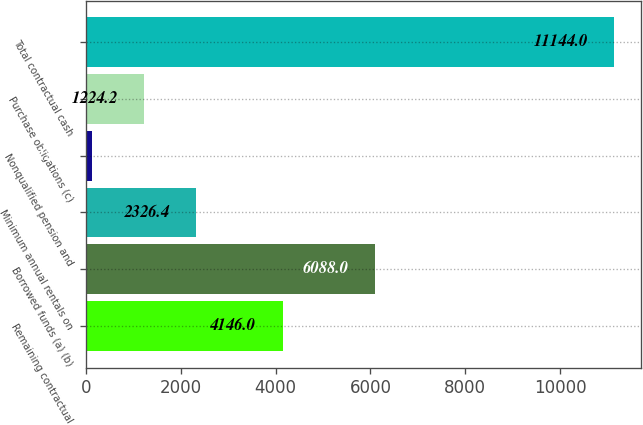Convert chart to OTSL. <chart><loc_0><loc_0><loc_500><loc_500><bar_chart><fcel>Remaining contractual<fcel>Borrowed funds (a) (b)<fcel>Minimum annual rentals on<fcel>Nonqualified pension and<fcel>Purchase obligations (c)<fcel>Total contractual cash<nl><fcel>4146<fcel>6088<fcel>2326.4<fcel>122<fcel>1224.2<fcel>11144<nl></chart> 